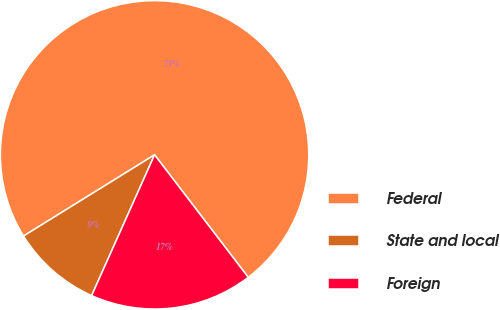<chart> <loc_0><loc_0><loc_500><loc_500><pie_chart><fcel>Federal<fcel>State and local<fcel>Foreign<nl><fcel>73.44%<fcel>9.48%<fcel>17.08%<nl></chart> 